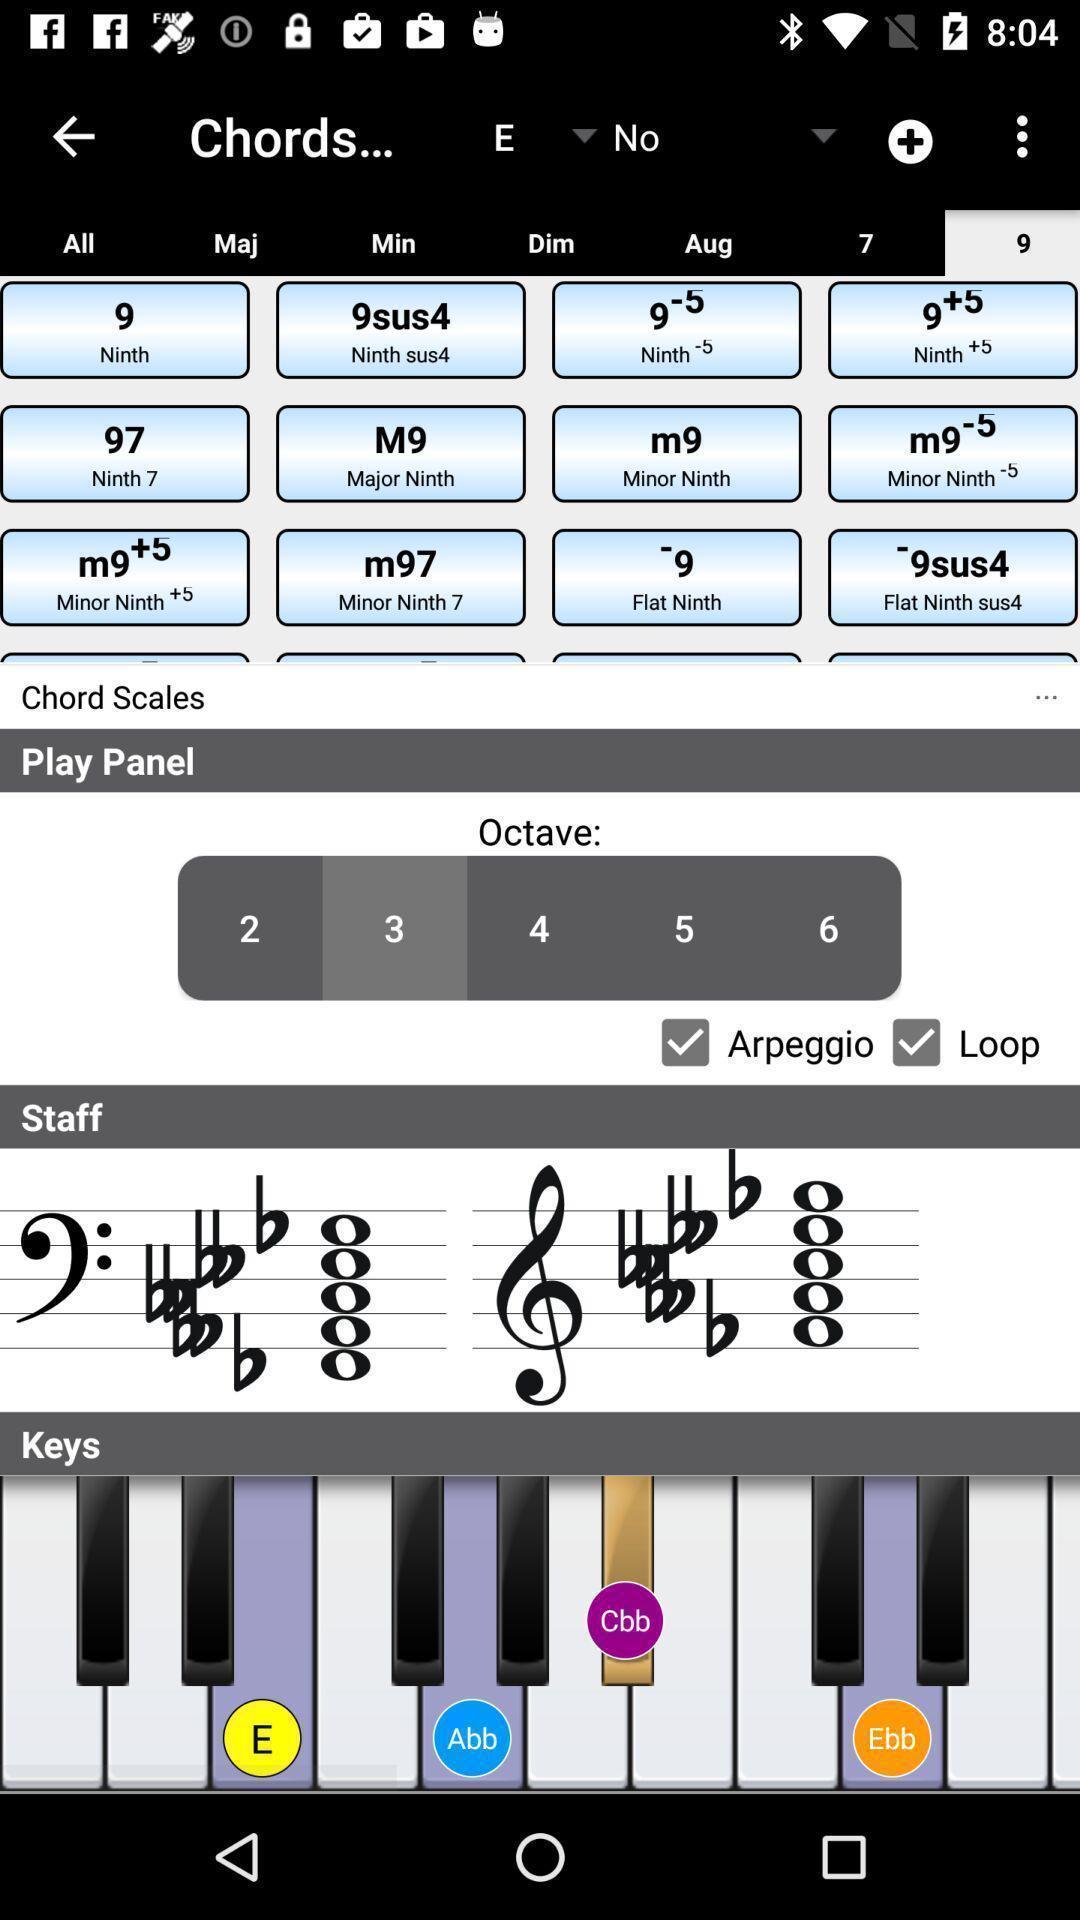Describe the content in this image. Screen page displaying multiple options in piano learning application. 